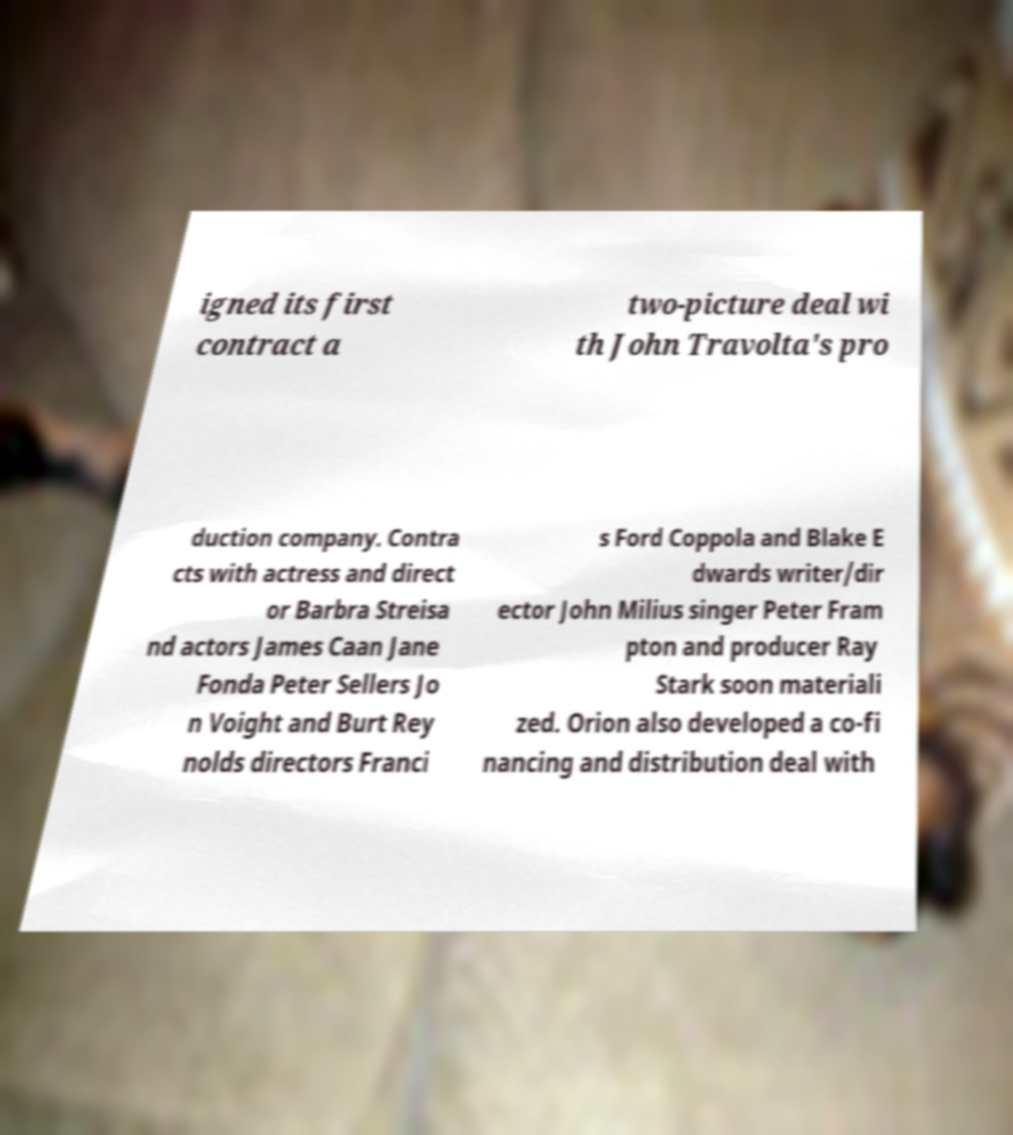Could you extract and type out the text from this image? igned its first contract a two-picture deal wi th John Travolta's pro duction company. Contra cts with actress and direct or Barbra Streisa nd actors James Caan Jane Fonda Peter Sellers Jo n Voight and Burt Rey nolds directors Franci s Ford Coppola and Blake E dwards writer/dir ector John Milius singer Peter Fram pton and producer Ray Stark soon materiali zed. Orion also developed a co-fi nancing and distribution deal with 